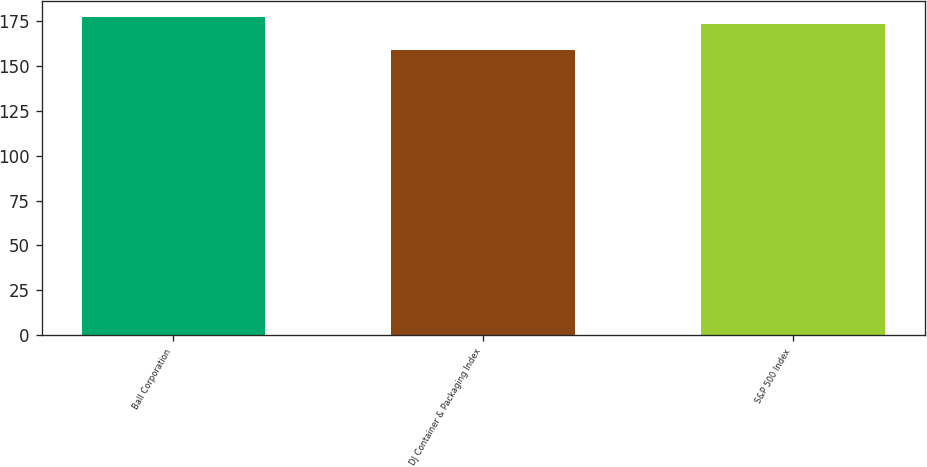Convert chart. <chart><loc_0><loc_0><loc_500><loc_500><bar_chart><fcel>Ball Corporation<fcel>DJ Container & Packaging Index<fcel>S&P 500 Index<nl><fcel>177.06<fcel>158.68<fcel>173.34<nl></chart> 